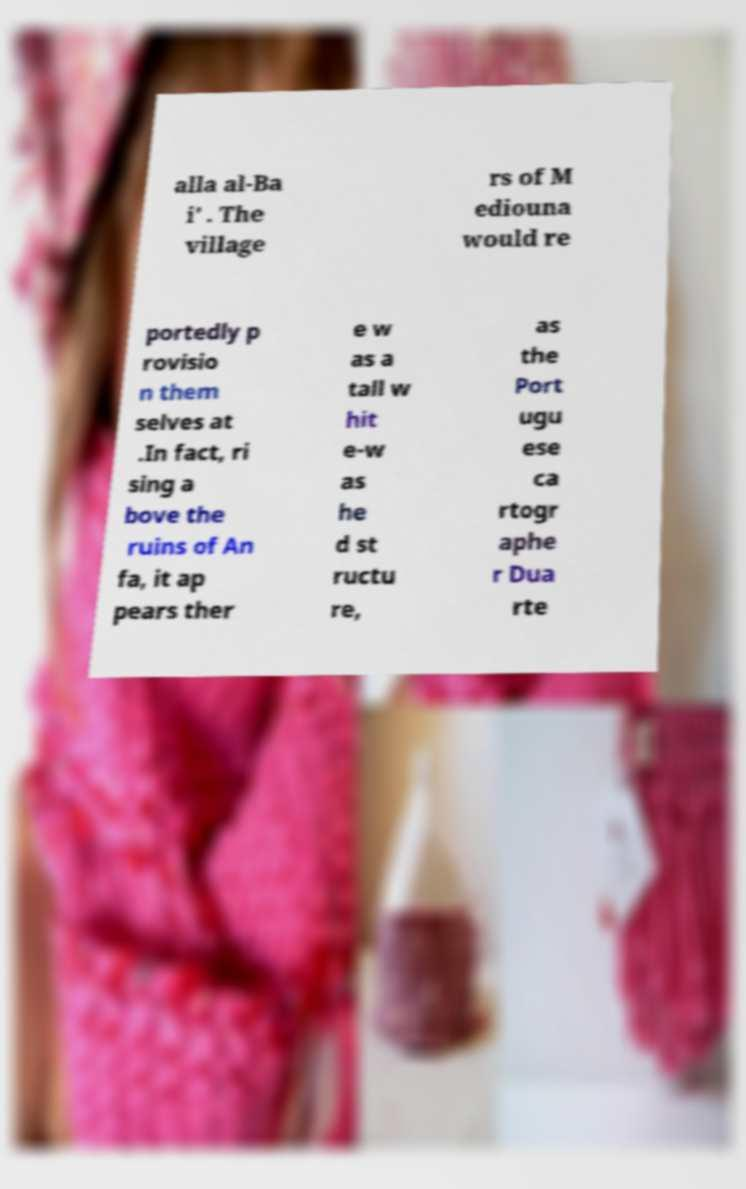There's text embedded in this image that I need extracted. Can you transcribe it verbatim? alla al-Ba i' . The village rs of M ediouna would re portedly p rovisio n them selves at .In fact, ri sing a bove the ruins of An fa, it ap pears ther e w as a tall w hit e-w as he d st ructu re, as the Port ugu ese ca rtogr aphe r Dua rte 